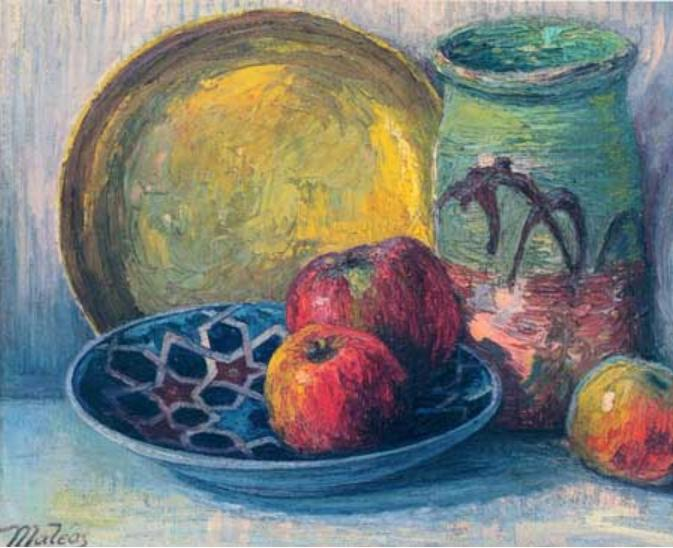Can you describe the main features of this image for me? This image showcases an impressionist still life painting that vividly illustrates a casual and informal arrangement of objects on a table. The artist, signed as 'Mateos', has masterfully employed oil on canvas to recreate this scene. Noteworthy is the technique used, characterized by loose and visible brushstrokes that infuse the painting with a dynamic sense of movement and energy.

At the heart of the composition are several objects: a yellow plate that provides a warm backdrop, a distinctively patterned blue bowl, a rustic green vase decorated with abstract designs, and vibrant red apples adding pops of color. Each element is rendered with a simplicity and directness true to the impressionist style - focusing on light, color interplay, and everyday subject matter. This painting is a beautifully nuanced portrayal within the impressionist genre, bringing ordinary objects to life with distinct vibrancy and expressiveness. 